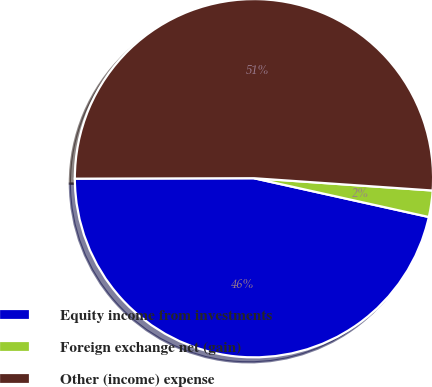Convert chart to OTSL. <chart><loc_0><loc_0><loc_500><loc_500><pie_chart><fcel>Equity income from investments<fcel>Foreign exchange net (gain)<fcel>Other (income) expense<nl><fcel>46.48%<fcel>2.38%<fcel>51.13%<nl></chart> 